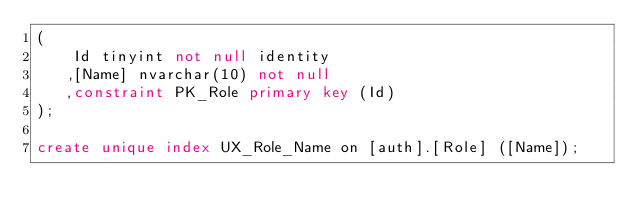<code> <loc_0><loc_0><loc_500><loc_500><_SQL_>(
	Id tinyint not null identity
   ,[Name] nvarchar(10) not null
   ,constraint PK_Role primary key (Id)
);

create unique index UX_Role_Name on [auth].[Role] ([Name]);</code> 